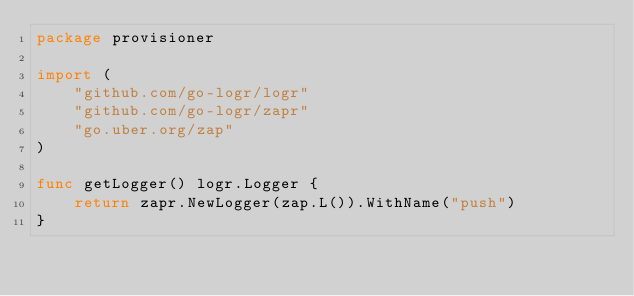Convert code to text. <code><loc_0><loc_0><loc_500><loc_500><_Go_>package provisioner

import (
	"github.com/go-logr/logr"
	"github.com/go-logr/zapr"
	"go.uber.org/zap"
)

func getLogger() logr.Logger {
	return zapr.NewLogger(zap.L()).WithName("push")
}
</code> 